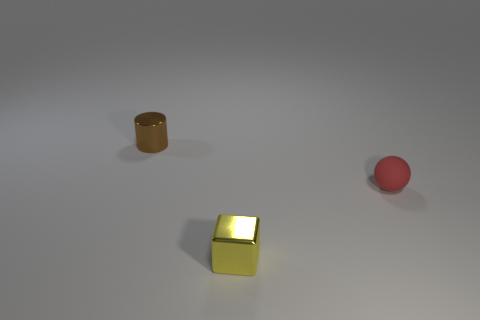What is the color of the object that is in front of the tiny brown metallic thing and behind the tiny yellow block?
Give a very brief answer. Red. There is a block; is it the same size as the object right of the small yellow metallic object?
Keep it short and to the point. Yes. Is there any other thing that is the same shape as the yellow object?
Your response must be concise. No. Is the brown metallic cylinder the same size as the red ball?
Provide a succinct answer. Yes. What number of other objects are the same size as the rubber sphere?
Provide a short and direct response. 2. What number of objects are either small metal objects that are in front of the brown metal cylinder or metal objects to the right of the small brown metallic object?
Offer a terse response. 1. There is a red thing that is the same size as the cube; what is its shape?
Offer a very short reply. Sphere. There is a yellow thing that is made of the same material as the brown cylinder; what size is it?
Your answer should be very brief. Small. There is a metallic cube that is the same size as the brown metallic cylinder; what is its color?
Provide a succinct answer. Yellow. There is a small metallic object in front of the cylinder; what shape is it?
Your answer should be compact. Cube. 